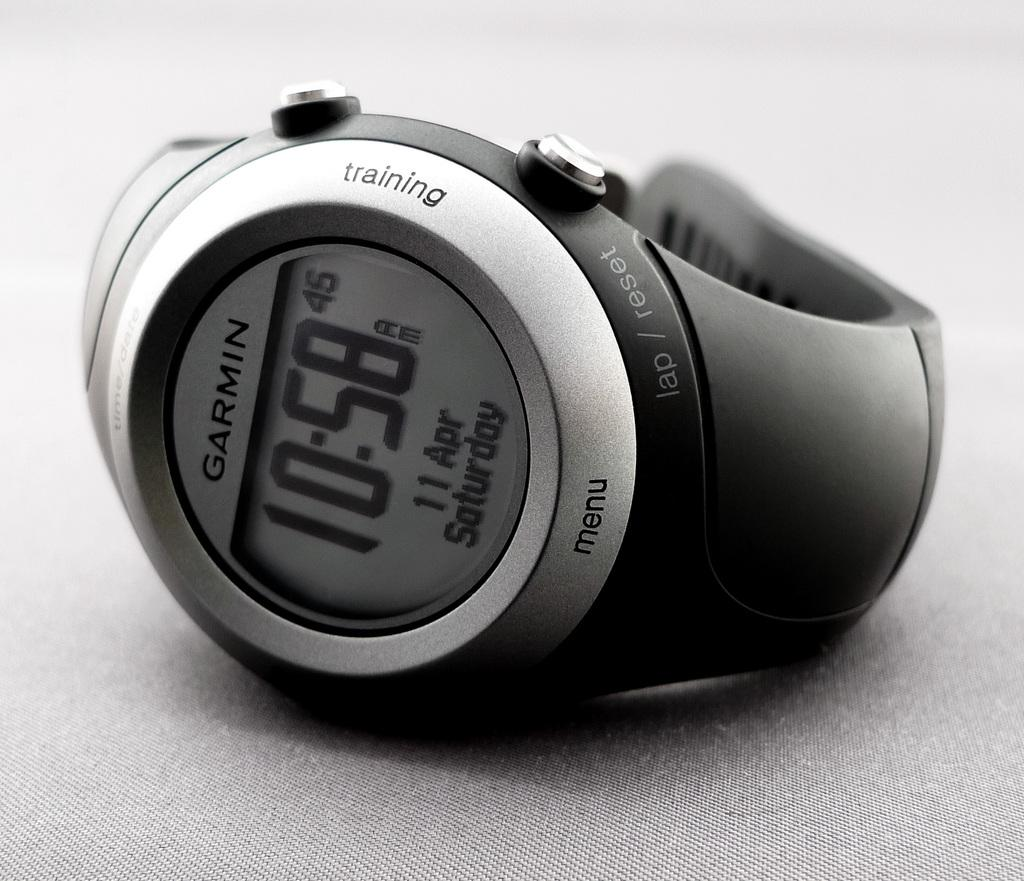Provide a one-sentence caption for the provided image. black watch with the time 10:58 fir the time. 